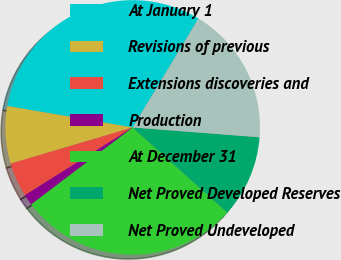Convert chart to OTSL. <chart><loc_0><loc_0><loc_500><loc_500><pie_chart><fcel>At January 1<fcel>Revisions of previous<fcel>Extensions discoveries and<fcel>Production<fcel>At December 31<fcel>Net Proved Developed Reserves<fcel>Net Proved Undeveloped<nl><fcel>30.95%<fcel>7.28%<fcel>4.34%<fcel>1.4%<fcel>28.01%<fcel>10.43%<fcel>17.58%<nl></chart> 